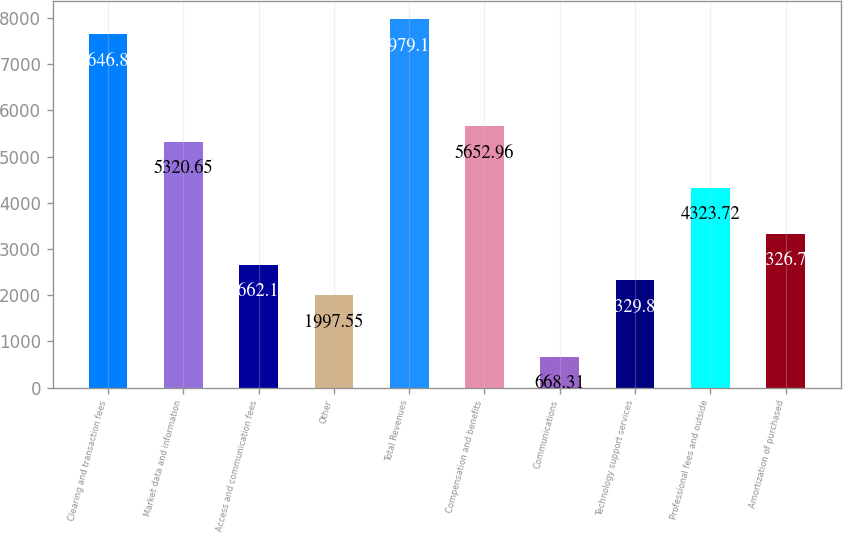Convert chart. <chart><loc_0><loc_0><loc_500><loc_500><bar_chart><fcel>Clearing and transaction fees<fcel>Market data and information<fcel>Access and communication fees<fcel>Other<fcel>Total Revenues<fcel>Compensation and benefits<fcel>Communications<fcel>Technology support services<fcel>Professional fees and outside<fcel>Amortization of purchased<nl><fcel>7646.82<fcel>5320.65<fcel>2662.17<fcel>1997.55<fcel>7979.13<fcel>5652.96<fcel>668.31<fcel>2329.86<fcel>4323.72<fcel>3326.79<nl></chart> 